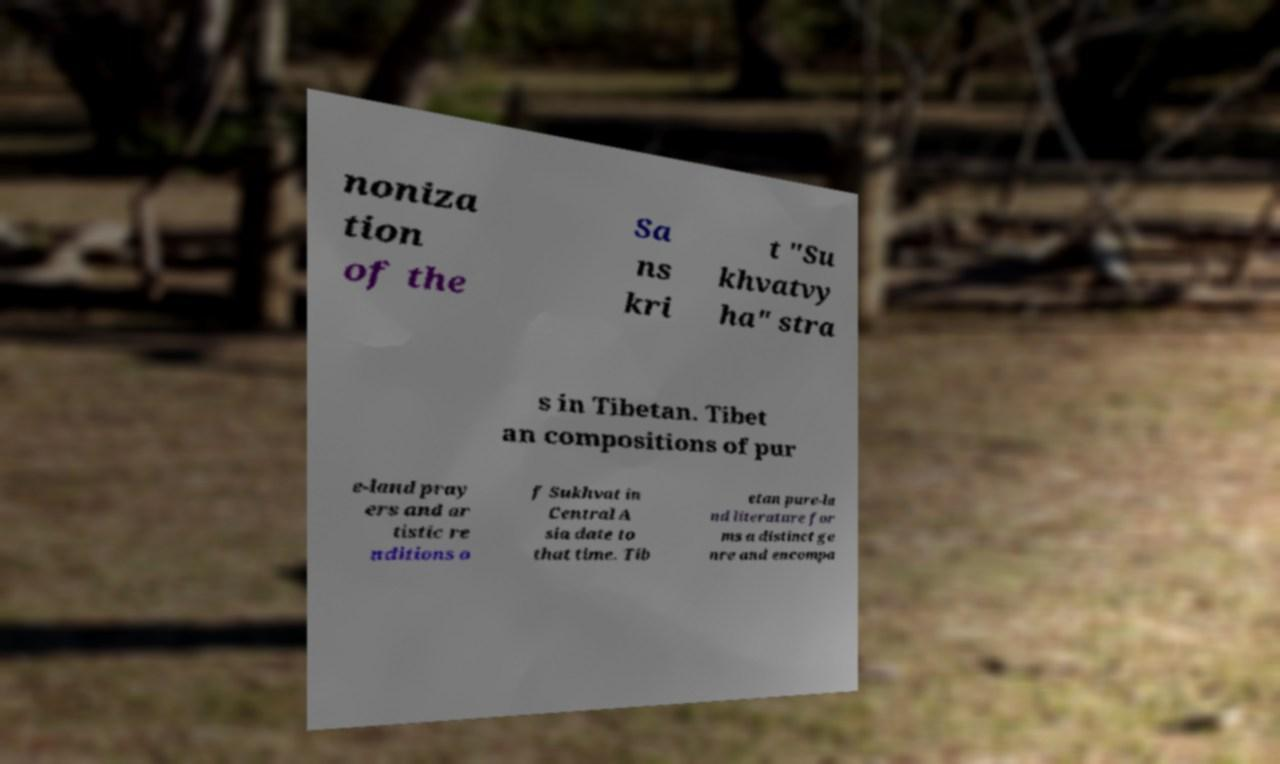Could you assist in decoding the text presented in this image and type it out clearly? noniza tion of the Sa ns kri t "Su khvatvy ha" stra s in Tibetan. Tibet an compositions of pur e-land pray ers and ar tistic re nditions o f Sukhvat in Central A sia date to that time. Tib etan pure-la nd literature for ms a distinct ge nre and encompa 